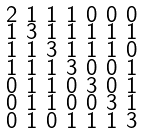Convert formula to latex. <formula><loc_0><loc_0><loc_500><loc_500>\begin{smallmatrix} 2 & 1 & 1 & 1 & 0 & 0 & 0 \\ 1 & 3 & 1 & 1 & 1 & 1 & 1 \\ 1 & 1 & 3 & 1 & 1 & 1 & 0 \\ 1 & 1 & 1 & 3 & 0 & 0 & 1 \\ 0 & 1 & 1 & 0 & 3 & 0 & 1 \\ 0 & 1 & 1 & 0 & 0 & 3 & 1 \\ 0 & 1 & 0 & 1 & 1 & 1 & 3 \end{smallmatrix}</formula> 